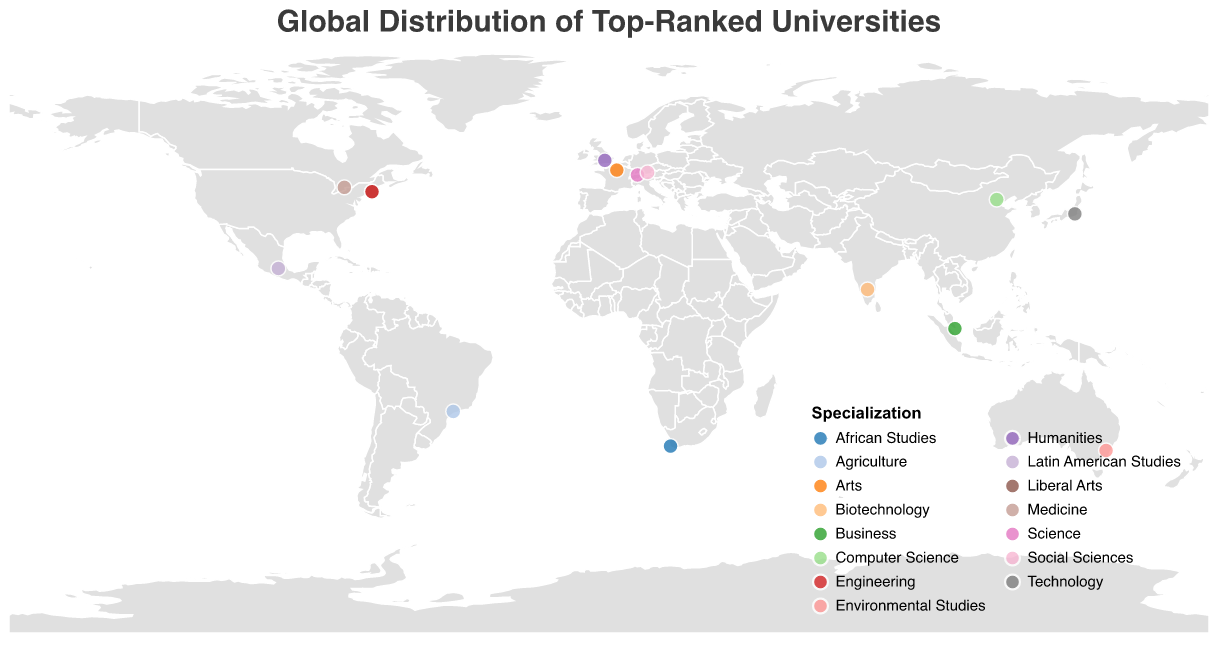How many universities from the USA are listed in the plot? By counting the data points for universities in the USA on the map, there are two: Harvard University and MIT.
Answer: 2 What is the specialization of the university ranked number 1? The tooltip on the plot shows that Harvard University is ranked number 1, and its specialization is Liberal Arts.
Answer: Liberal Arts Which continent has the most diverse specializations among its top-ranked universities? By examining the location and specialization of universities on different continents, North America (which includes universities in the USA and Canada) shows multiple specializations such as Liberal Arts, Engineering, and Medicine.
Answer: North America Are there more universities with a specialization in technology or social sciences? By looking at the specialization field, there is one university for Technology (University of Tokyo) and one for Social Sciences (LMU Munich). They are equal in number.
Answer: Equal Which university is the southernmost among the top-ranked ones? By looking at the latitude coordinates, the university with the lowest (most negative) latitude is the Australian National University in Australia.
Answer: Australian National University What is the color representing the specialization 'Medicine'? The legend on the map shows that each specialization has a distinct color. The color used for 'Medicine' can be identified based on the University of Toronto's color.
Answer: Refer to the map for the specific color Compare the ranks of the universities from the UK and Singapore. Which one is higher? University of Oxford (UK) is ranked 2, and National University of Singapore is ranked 4. Thus, the UK university has a higher rank.
Answer: UK Which country in South America has a top-ranked university, and what is its specialization? The data points show one university in Brazil (University of São Paulo) with a specialization in Agriculture.
Answer: Brazil, Agriculture What is the average rank of the universities in Europe according to the plot? Europe has four universities: University of Oxford (2), ETH Zurich (5), LMU Munich (10), and Sorbonne University (14). Their average rank is (2+5+10+14)/4 = 7.75.
Answer: 7.75 Identify a university located in Africa and specify its specialization. The university located in Africa is the University of Cape Town, with a specialization in African Studies.
Answer: University of Cape Town, African Studies 